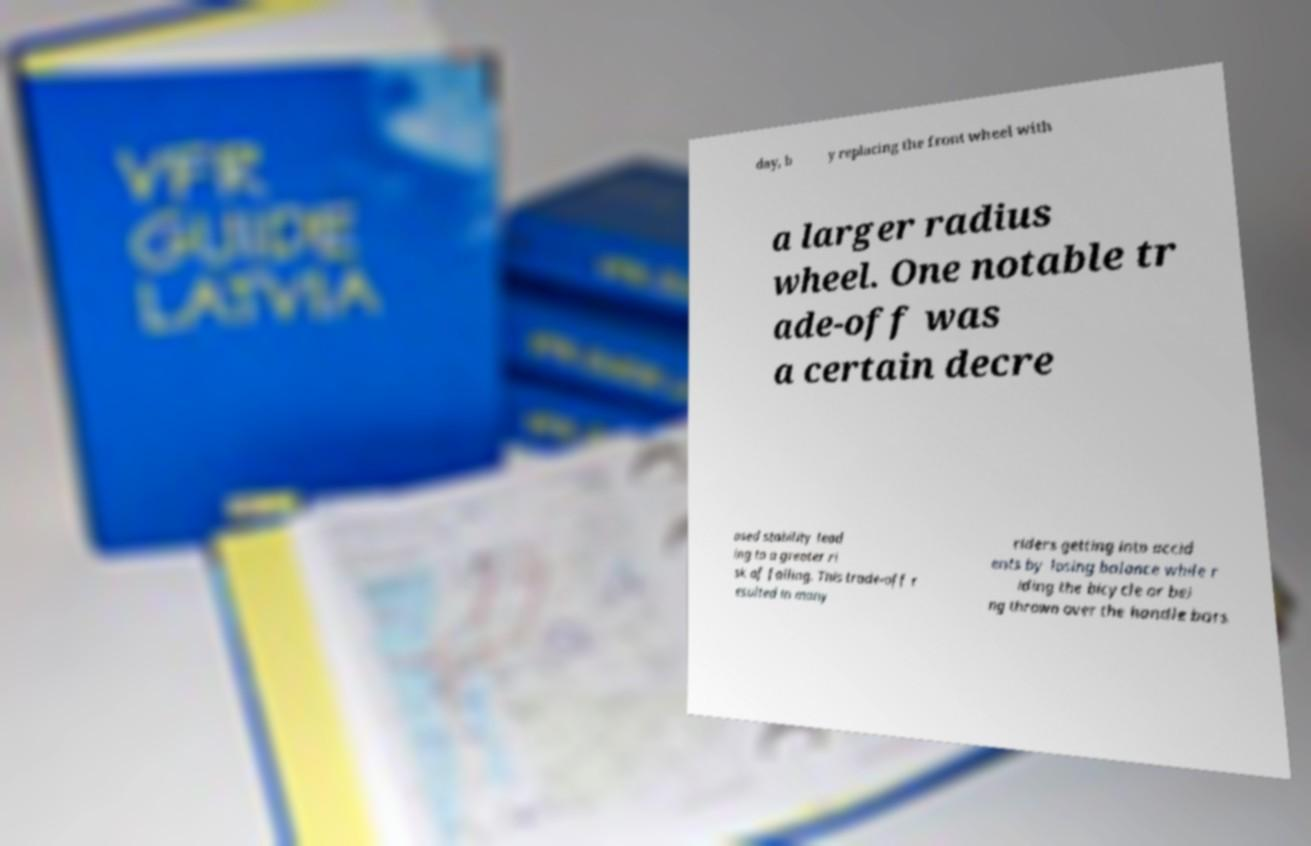Could you extract and type out the text from this image? day, b y replacing the front wheel with a larger radius wheel. One notable tr ade-off was a certain decre ased stability lead ing to a greater ri sk of falling. This trade-off r esulted in many riders getting into accid ents by losing balance while r iding the bicycle or bei ng thrown over the handle bars 